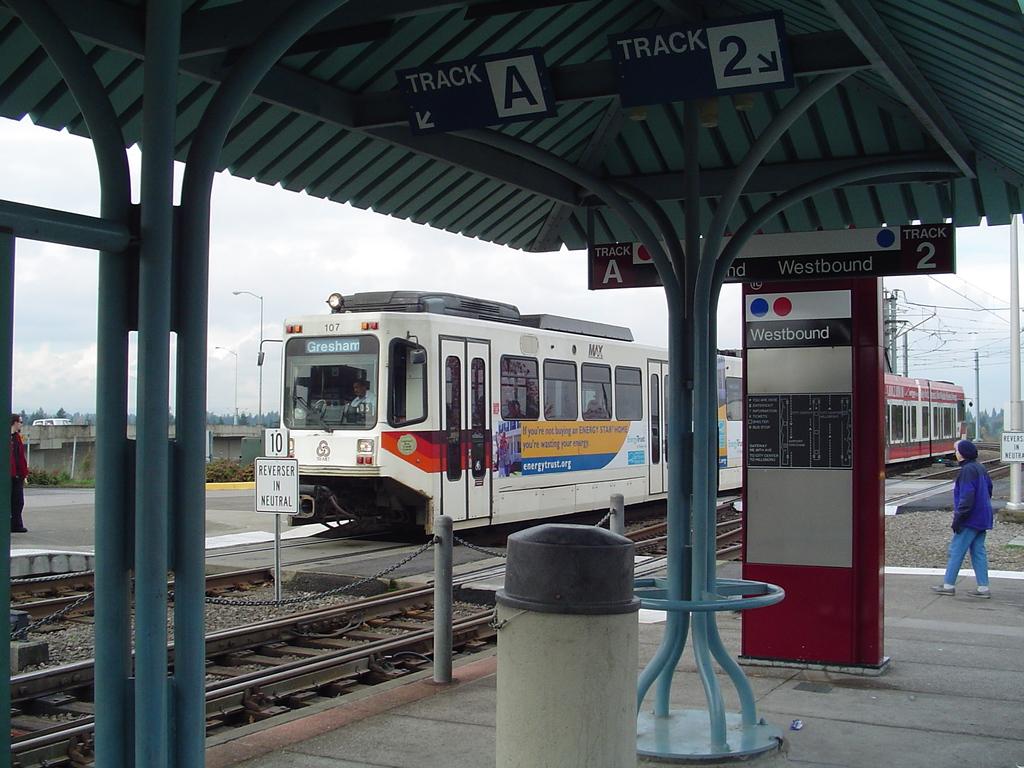Are these people traveling westbound?
Provide a succinct answer. Yes. Which track is to the left?
Your response must be concise. A. 